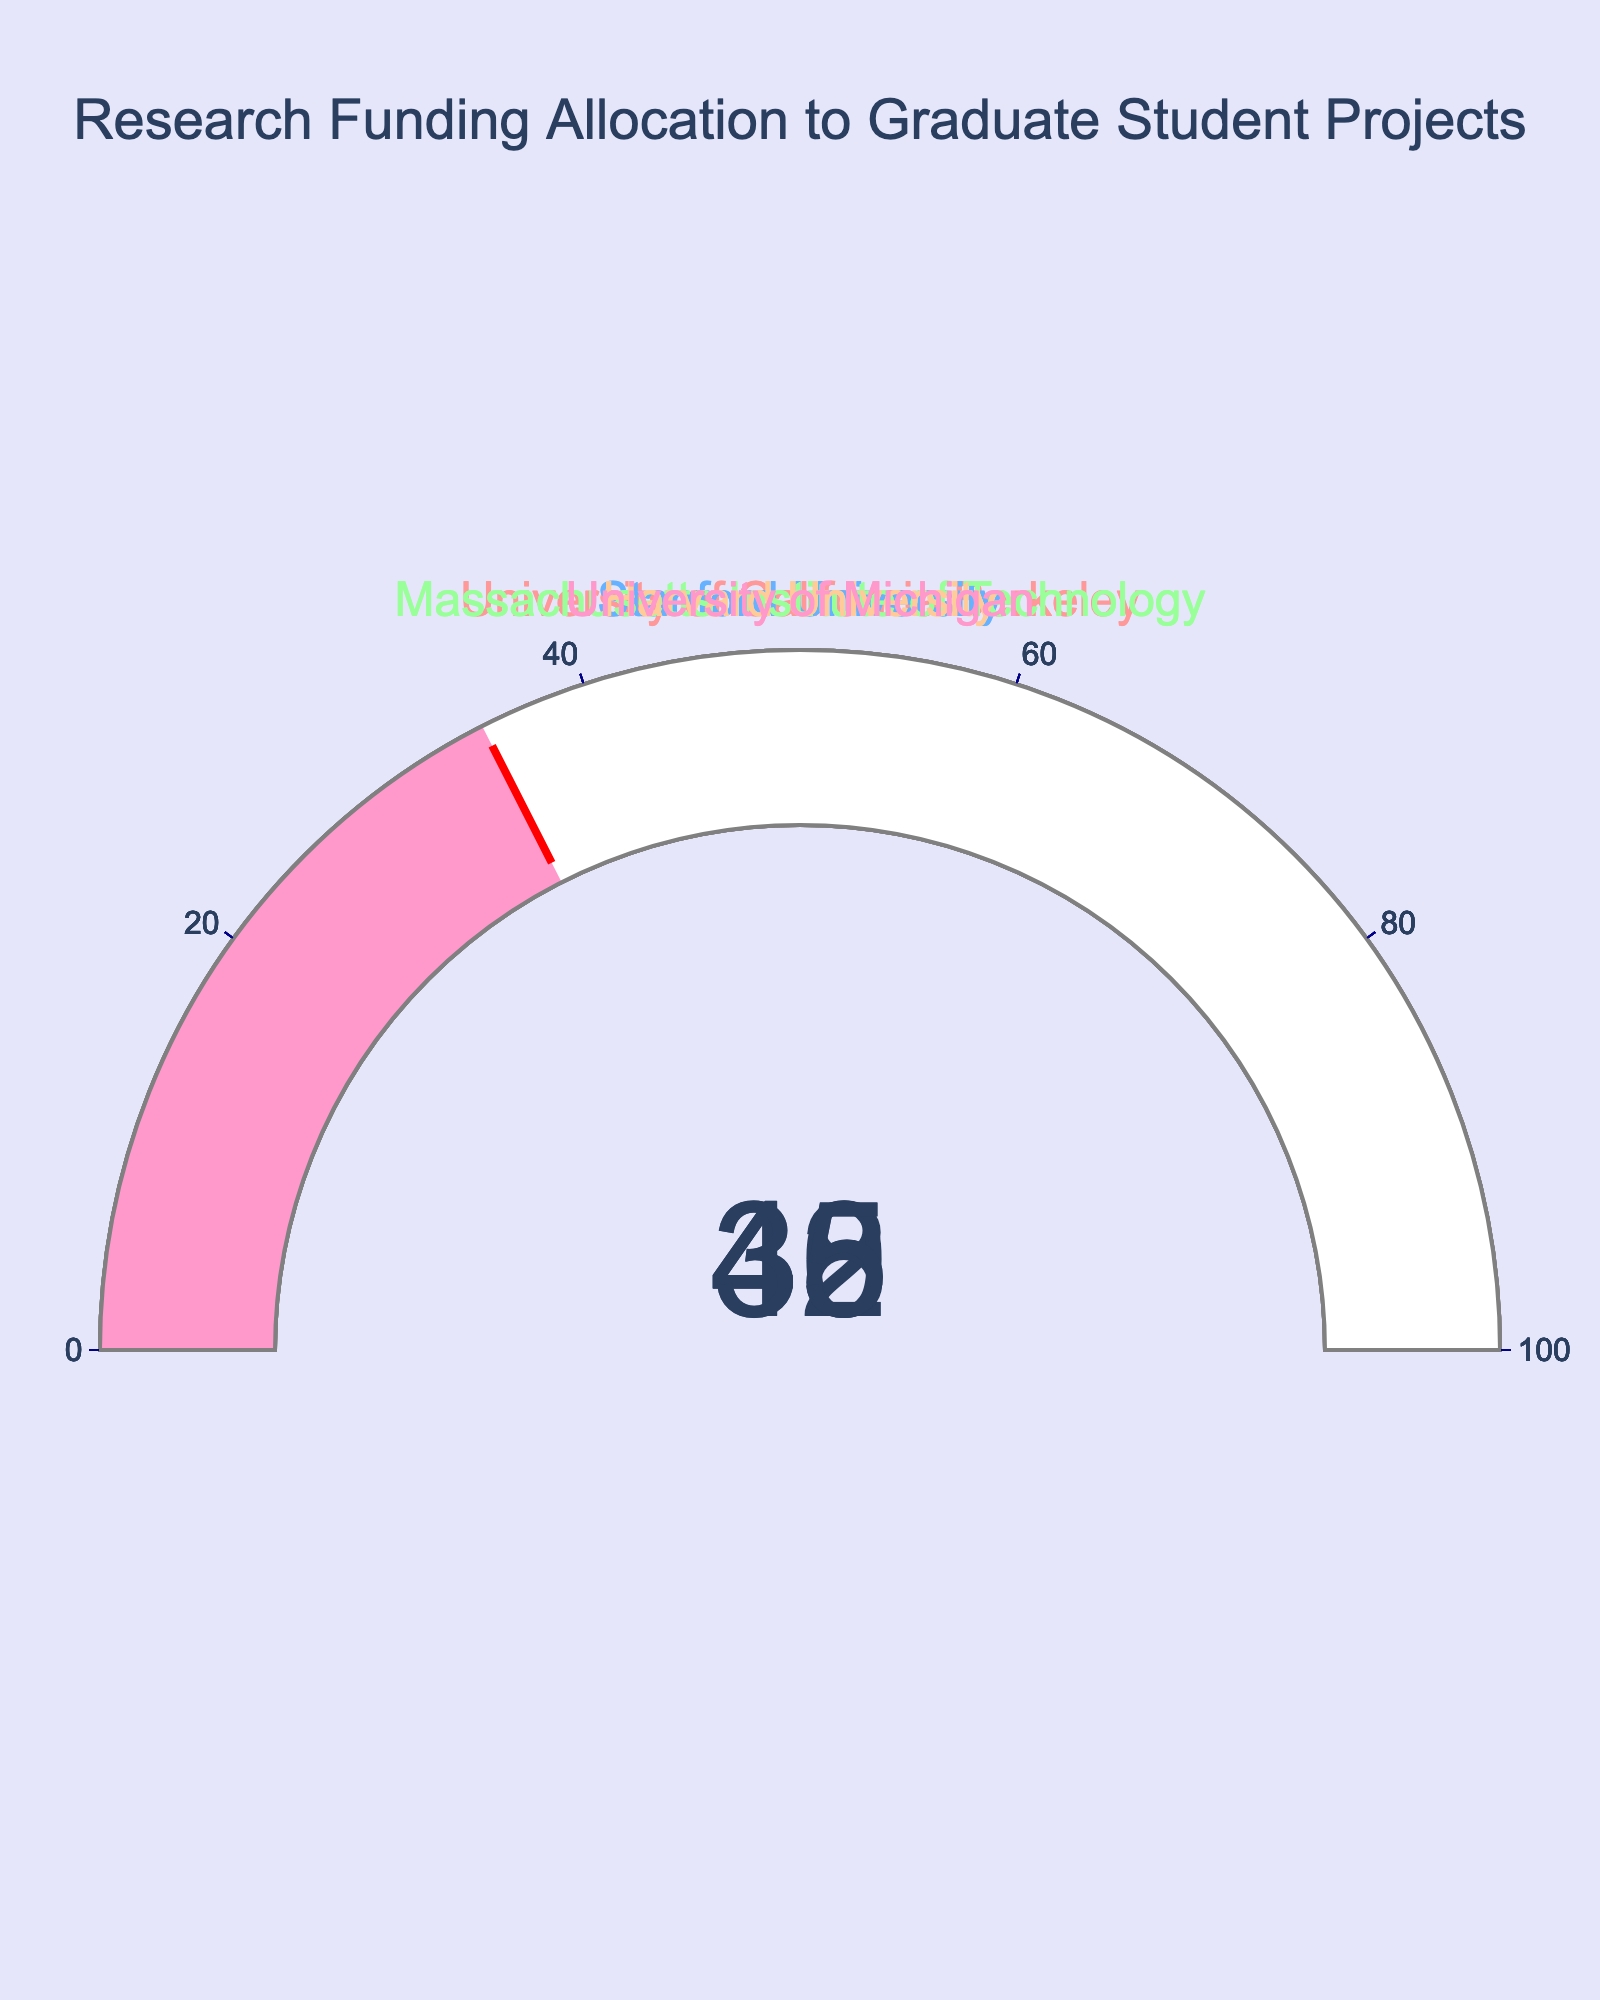what is the highest percentage value displayed in the gauges? The highest percentage can be obtained by inspecting each gauge. The values are 42, 38, 45, 40, and 35. The highest value among these is 45, which corresponds to Massachusetts Institute of Technology.
Answer: 45 how many universities have a funding percentage above 40%? By looking at the gauges, we note the percentage values for each university: 42, 38, 45, 40, and 35. The universities with percentages above 40% are University of California Berkeley (42), Massachusetts Institute of Technology (45), and Harvard University (40). Hence, two universities exceed 40%.
Answer: 3 which university has the lowest allocation of research funding to graduate student projects? To find the university with the lowest research funding, we compare all the values: University of California Berkeley (42), Stanford University (38), Massachusetts Institute of Technology (45), Harvard University (40), and University of Michigan (35). The lowest percentage value is 35, which belongs to the University of Michigan.
Answer: University of Michigan what is the average funding percentage for all listed universities? The percentages are 42 (UC Berkeley), 38 (Stanford), 45 (MIT), 40 (Harvard), and 35 (University of Michigan). Adding these numbers: 42 + 38 + 45 + 40 + 35 = 200. Dividing by the number of universities (5), we get an average funding percentage of 40.
Answer: 40 which university’s gauge has the color #FFCC99? The expertise requires recognizing colors associated with each university. According to the color list provided, #FFCC99 is the fourth color indicating Harvard University.
Answer: Harvard University how much more funding does MIT allocate compared to the University of Michigan? MIT allocates 45% while the University of Michigan allocates 35%. The difference is computed as 45 - 35 = 10. MIT allocates 10% more funding compared to the University of Michigan.
Answer: 10 if the threshold indicator shows, which color and thickness does it have on each gauge? The threshold indicators on each gauge have a red color with a thickness of 0.75. This is uniform across all gauges.
Answer: red, 0.75 